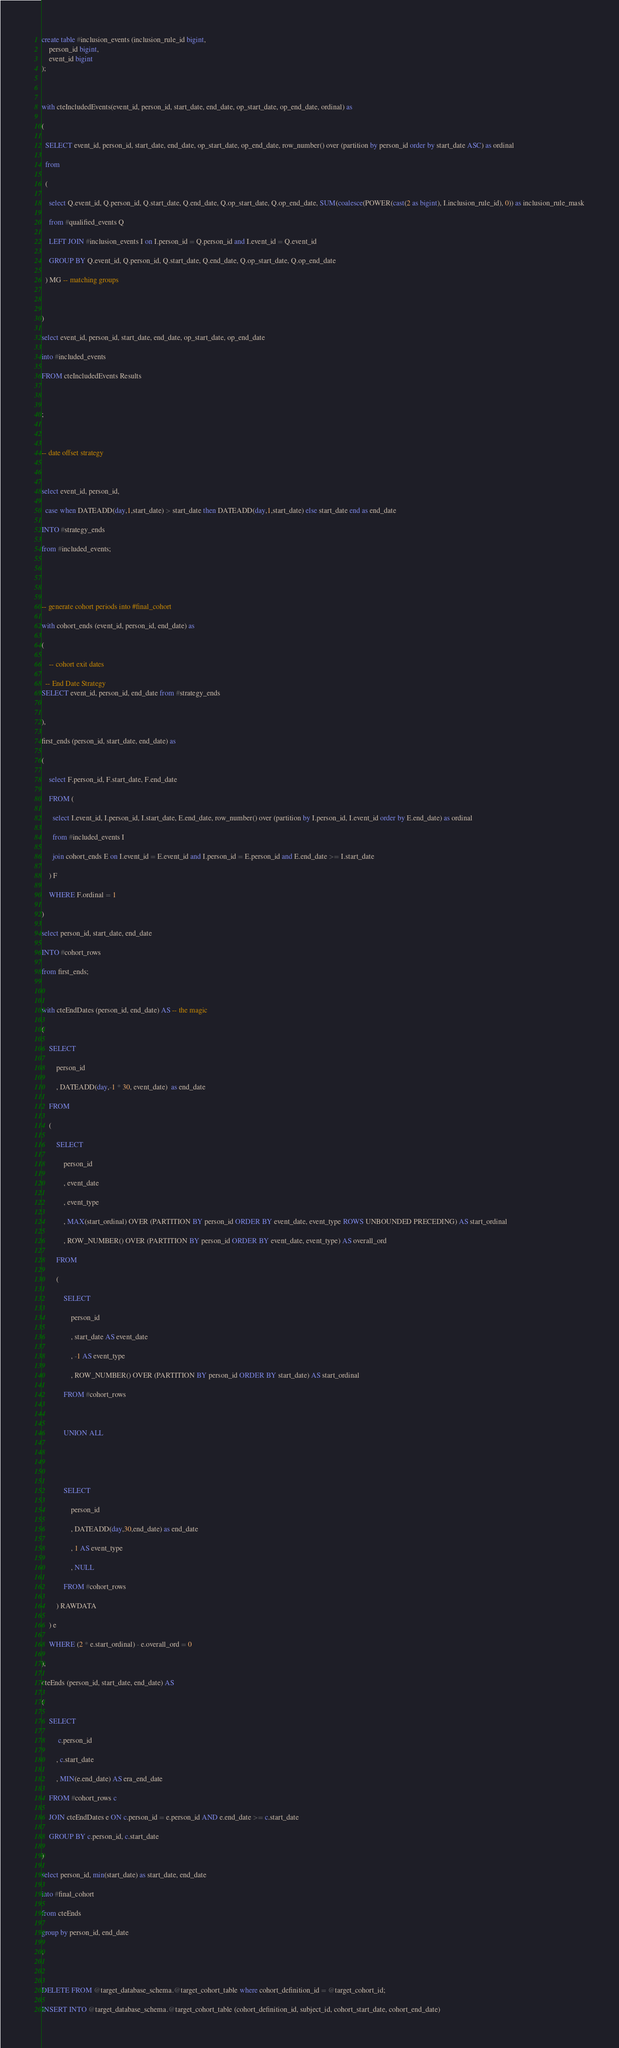Convert code to text. <code><loc_0><loc_0><loc_500><loc_500><_SQL_>create table #inclusion_events (inclusion_rule_id bigint,
	person_id bigint,
	event_id bigint
);

with cteIncludedEvents(event_id, person_id, start_date, end_date, op_start_date, op_end_date, ordinal) as
(
  SELECT event_id, person_id, start_date, end_date, op_start_date, op_end_date, row_number() over (partition by person_id order by start_date ASC) as ordinal
  from
  (
    select Q.event_id, Q.person_id, Q.start_date, Q.end_date, Q.op_start_date, Q.op_end_date, SUM(coalesce(POWER(cast(2 as bigint), I.inclusion_rule_id), 0)) as inclusion_rule_mask
    from #qualified_events Q
    LEFT JOIN #inclusion_events I on I.person_id = Q.person_id and I.event_id = Q.event_id
    GROUP BY Q.event_id, Q.person_id, Q.start_date, Q.end_date, Q.op_start_date, Q.op_end_date
  ) MG -- matching groups

)
select event_id, person_id, start_date, end_date, op_start_date, op_end_date
into #included_events
FROM cteIncludedEvents Results

;

-- date offset strategy

select event_id, person_id, 
  case when DATEADD(day,1,start_date) > start_date then DATEADD(day,1,start_date) else start_date end as end_date
INTO #strategy_ends
from #included_events;


-- generate cohort periods into #final_cohort
with cohort_ends (event_id, person_id, end_date) as
(
	-- cohort exit dates
  -- End Date Strategy
SELECT event_id, person_id, end_date from #strategy_ends

),
first_ends (person_id, start_date, end_date) as
(
	select F.person_id, F.start_date, F.end_date
	FROM (
	  select I.event_id, I.person_id, I.start_date, E.end_date, row_number() over (partition by I.person_id, I.event_id order by E.end_date) as ordinal 
	  from #included_events I
	  join cohort_ends E on I.event_id = E.event_id and I.person_id = E.person_id and E.end_date >= I.start_date
	) F
	WHERE F.ordinal = 1
)
select person_id, start_date, end_date
INTO #cohort_rows
from first_ends;

with cteEndDates (person_id, end_date) AS -- the magic
(	
	SELECT
		person_id
		, DATEADD(day,-1 * 30, event_date)  as end_date
	FROM
	(
		SELECT
			person_id
			, event_date
			, event_type
			, MAX(start_ordinal) OVER (PARTITION BY person_id ORDER BY event_date, event_type ROWS UNBOUNDED PRECEDING) AS start_ordinal 
			, ROW_NUMBER() OVER (PARTITION BY person_id ORDER BY event_date, event_type) AS overall_ord
		FROM
		(
			SELECT
				person_id
				, start_date AS event_date
				, -1 AS event_type
				, ROW_NUMBER() OVER (PARTITION BY person_id ORDER BY start_date) AS start_ordinal
			FROM #cohort_rows
		
			UNION ALL
		

			SELECT
				person_id
				, DATEADD(day,30,end_date) as end_date
				, 1 AS event_type
				, NULL
			FROM #cohort_rows
		) RAWDATA
	) e
	WHERE (2 * e.start_ordinal) - e.overall_ord = 0
),
cteEnds (person_id, start_date, end_date) AS
(
	SELECT
		 c.person_id
		, c.start_date
		, MIN(e.end_date) AS era_end_date
	FROM #cohort_rows c
	JOIN cteEndDates e ON c.person_id = e.person_id AND e.end_date >= c.start_date
	GROUP BY c.person_id, c.start_date
)
select person_id, min(start_date) as start_date, end_date
into #final_cohort
from cteEnds
group by person_id, end_date
;

DELETE FROM @target_database_schema.@target_cohort_table where cohort_definition_id = @target_cohort_id;
INSERT INTO @target_database_schema.@target_cohort_table (cohort_definition_id, subject_id, cohort_start_date, cohort_end_date)</code> 